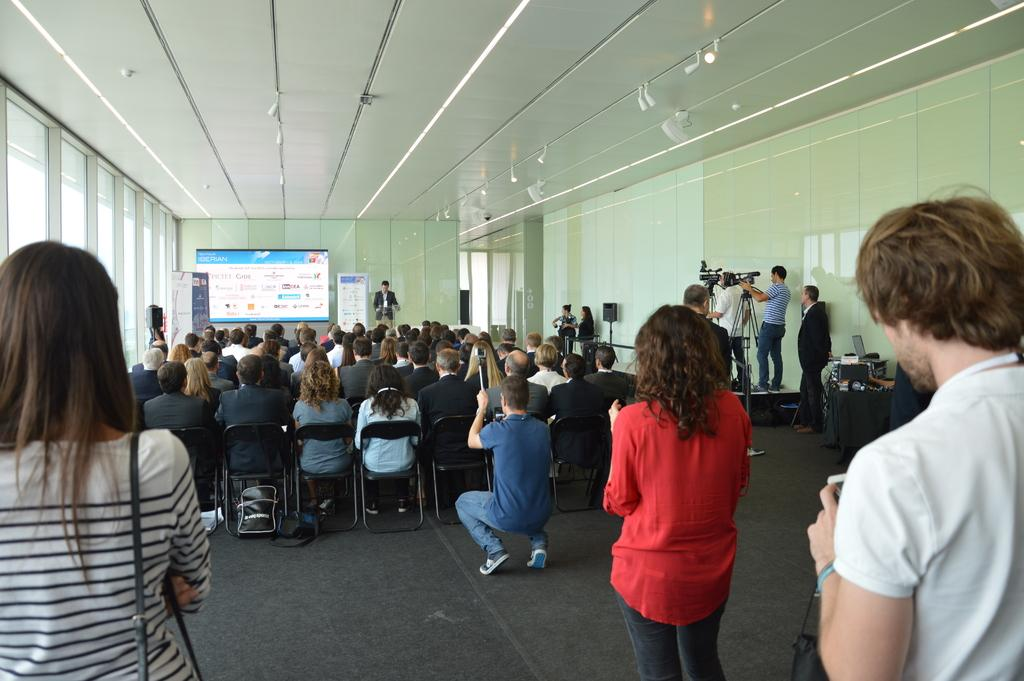How many people are in the image? There is a group of people in the image. What are some of the people in the image doing? Some people are sitting on chairs, while others are standing. What can be seen in the background of the image? There is a screen, a wall, and a roof in the background of the image. What type of berry is being discussed by the ghost on the screen in the image? There is no ghost or discussion of berries in the image; it features a group of people and a screen in the background. 